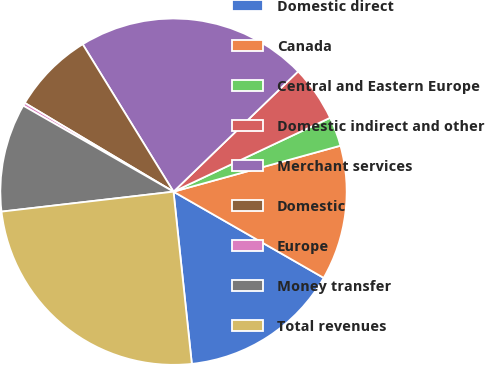<chart> <loc_0><loc_0><loc_500><loc_500><pie_chart><fcel>Domestic direct<fcel>Canada<fcel>Central and Eastern Europe<fcel>Domestic indirect and other<fcel>Merchant services<fcel>Domestic<fcel>Europe<fcel>Money transfer<fcel>Total revenues<nl><fcel>15.02%<fcel>12.57%<fcel>2.74%<fcel>5.2%<fcel>21.57%<fcel>7.65%<fcel>0.29%<fcel>10.11%<fcel>24.85%<nl></chart> 